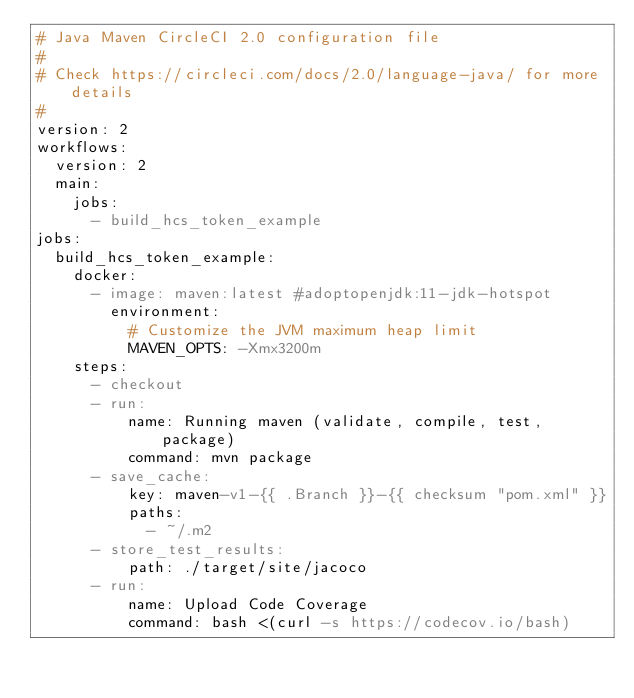<code> <loc_0><loc_0><loc_500><loc_500><_YAML_># Java Maven CircleCI 2.0 configuration file
#
# Check https://circleci.com/docs/2.0/language-java/ for more details
#
version: 2
workflows:
  version: 2
  main:
    jobs:
      - build_hcs_token_example
jobs:
  build_hcs_token_example:
    docker:
      - image: maven:latest #adoptopenjdk:11-jdk-hotspot
        environment:
          # Customize the JVM maximum heap limit
          MAVEN_OPTS: -Xmx3200m
    steps:
      - checkout
      - run:
          name: Running maven (validate, compile, test, package)
          command: mvn package
      - save_cache:
          key: maven-v1-{{ .Branch }}-{{ checksum "pom.xml" }}
          paths:
            - ~/.m2
      - store_test_results:
          path: ./target/site/jacoco
      - run:
          name: Upload Code Coverage
          command: bash <(curl -s https://codecov.io/bash)
</code> 